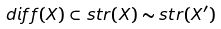<formula> <loc_0><loc_0><loc_500><loc_500>d i f f ( X ) \subset s t r ( X ) \sim s t r ( X ^ { \prime } )</formula> 